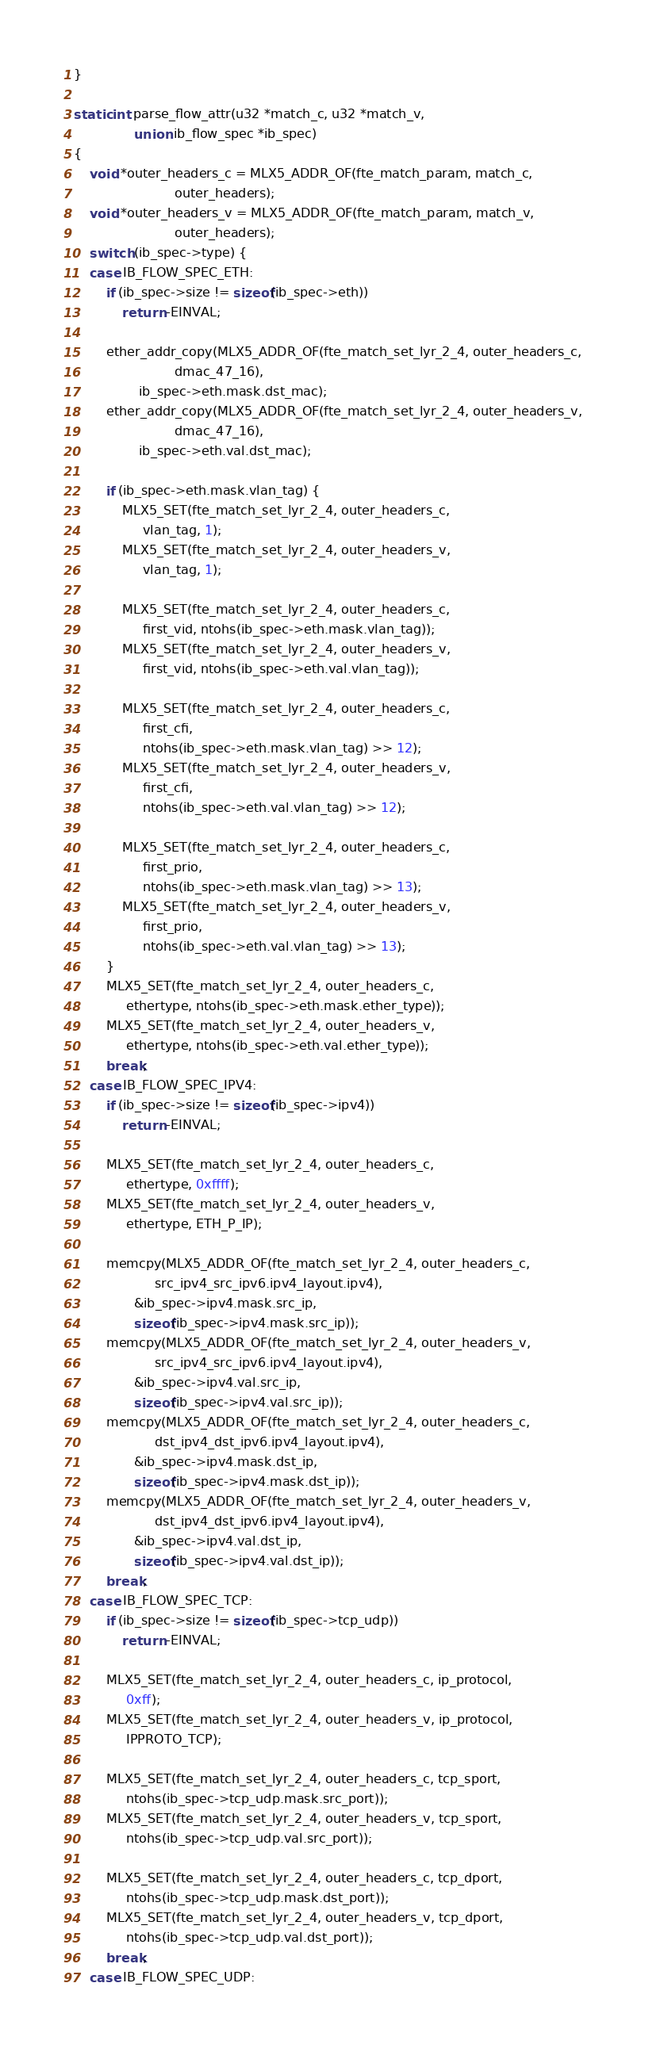Convert code to text. <code><loc_0><loc_0><loc_500><loc_500><_C_>}

static int parse_flow_attr(u32 *match_c, u32 *match_v,
			   union ib_flow_spec *ib_spec)
{
	void *outer_headers_c = MLX5_ADDR_OF(fte_match_param, match_c,
					     outer_headers);
	void *outer_headers_v = MLX5_ADDR_OF(fte_match_param, match_v,
					     outer_headers);
	switch (ib_spec->type) {
	case IB_FLOW_SPEC_ETH:
		if (ib_spec->size != sizeof(ib_spec->eth))
			return -EINVAL;

		ether_addr_copy(MLX5_ADDR_OF(fte_match_set_lyr_2_4, outer_headers_c,
					     dmac_47_16),
				ib_spec->eth.mask.dst_mac);
		ether_addr_copy(MLX5_ADDR_OF(fte_match_set_lyr_2_4, outer_headers_v,
					     dmac_47_16),
				ib_spec->eth.val.dst_mac);

		if (ib_spec->eth.mask.vlan_tag) {
			MLX5_SET(fte_match_set_lyr_2_4, outer_headers_c,
				 vlan_tag, 1);
			MLX5_SET(fte_match_set_lyr_2_4, outer_headers_v,
				 vlan_tag, 1);

			MLX5_SET(fte_match_set_lyr_2_4, outer_headers_c,
				 first_vid, ntohs(ib_spec->eth.mask.vlan_tag));
			MLX5_SET(fte_match_set_lyr_2_4, outer_headers_v,
				 first_vid, ntohs(ib_spec->eth.val.vlan_tag));

			MLX5_SET(fte_match_set_lyr_2_4, outer_headers_c,
				 first_cfi,
				 ntohs(ib_spec->eth.mask.vlan_tag) >> 12);
			MLX5_SET(fte_match_set_lyr_2_4, outer_headers_v,
				 first_cfi,
				 ntohs(ib_spec->eth.val.vlan_tag) >> 12);

			MLX5_SET(fte_match_set_lyr_2_4, outer_headers_c,
				 first_prio,
				 ntohs(ib_spec->eth.mask.vlan_tag) >> 13);
			MLX5_SET(fte_match_set_lyr_2_4, outer_headers_v,
				 first_prio,
				 ntohs(ib_spec->eth.val.vlan_tag) >> 13);
		}
		MLX5_SET(fte_match_set_lyr_2_4, outer_headers_c,
			 ethertype, ntohs(ib_spec->eth.mask.ether_type));
		MLX5_SET(fte_match_set_lyr_2_4, outer_headers_v,
			 ethertype, ntohs(ib_spec->eth.val.ether_type));
		break;
	case IB_FLOW_SPEC_IPV4:
		if (ib_spec->size != sizeof(ib_spec->ipv4))
			return -EINVAL;

		MLX5_SET(fte_match_set_lyr_2_4, outer_headers_c,
			 ethertype, 0xffff);
		MLX5_SET(fte_match_set_lyr_2_4, outer_headers_v,
			 ethertype, ETH_P_IP);

		memcpy(MLX5_ADDR_OF(fte_match_set_lyr_2_4, outer_headers_c,
				    src_ipv4_src_ipv6.ipv4_layout.ipv4),
		       &ib_spec->ipv4.mask.src_ip,
		       sizeof(ib_spec->ipv4.mask.src_ip));
		memcpy(MLX5_ADDR_OF(fte_match_set_lyr_2_4, outer_headers_v,
				    src_ipv4_src_ipv6.ipv4_layout.ipv4),
		       &ib_spec->ipv4.val.src_ip,
		       sizeof(ib_spec->ipv4.val.src_ip));
		memcpy(MLX5_ADDR_OF(fte_match_set_lyr_2_4, outer_headers_c,
				    dst_ipv4_dst_ipv6.ipv4_layout.ipv4),
		       &ib_spec->ipv4.mask.dst_ip,
		       sizeof(ib_spec->ipv4.mask.dst_ip));
		memcpy(MLX5_ADDR_OF(fte_match_set_lyr_2_4, outer_headers_v,
				    dst_ipv4_dst_ipv6.ipv4_layout.ipv4),
		       &ib_spec->ipv4.val.dst_ip,
		       sizeof(ib_spec->ipv4.val.dst_ip));
		break;
	case IB_FLOW_SPEC_TCP:
		if (ib_spec->size != sizeof(ib_spec->tcp_udp))
			return -EINVAL;

		MLX5_SET(fte_match_set_lyr_2_4, outer_headers_c, ip_protocol,
			 0xff);
		MLX5_SET(fte_match_set_lyr_2_4, outer_headers_v, ip_protocol,
			 IPPROTO_TCP);

		MLX5_SET(fte_match_set_lyr_2_4, outer_headers_c, tcp_sport,
			 ntohs(ib_spec->tcp_udp.mask.src_port));
		MLX5_SET(fte_match_set_lyr_2_4, outer_headers_v, tcp_sport,
			 ntohs(ib_spec->tcp_udp.val.src_port));

		MLX5_SET(fte_match_set_lyr_2_4, outer_headers_c, tcp_dport,
			 ntohs(ib_spec->tcp_udp.mask.dst_port));
		MLX5_SET(fte_match_set_lyr_2_4, outer_headers_v, tcp_dport,
			 ntohs(ib_spec->tcp_udp.val.dst_port));
		break;
	case IB_FLOW_SPEC_UDP:</code> 